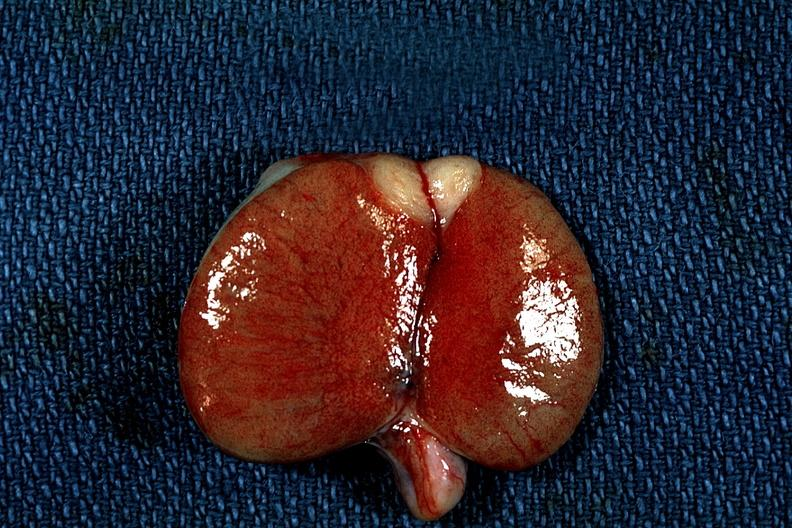s testicle present?
Answer the question using a single word or phrase. Yes 